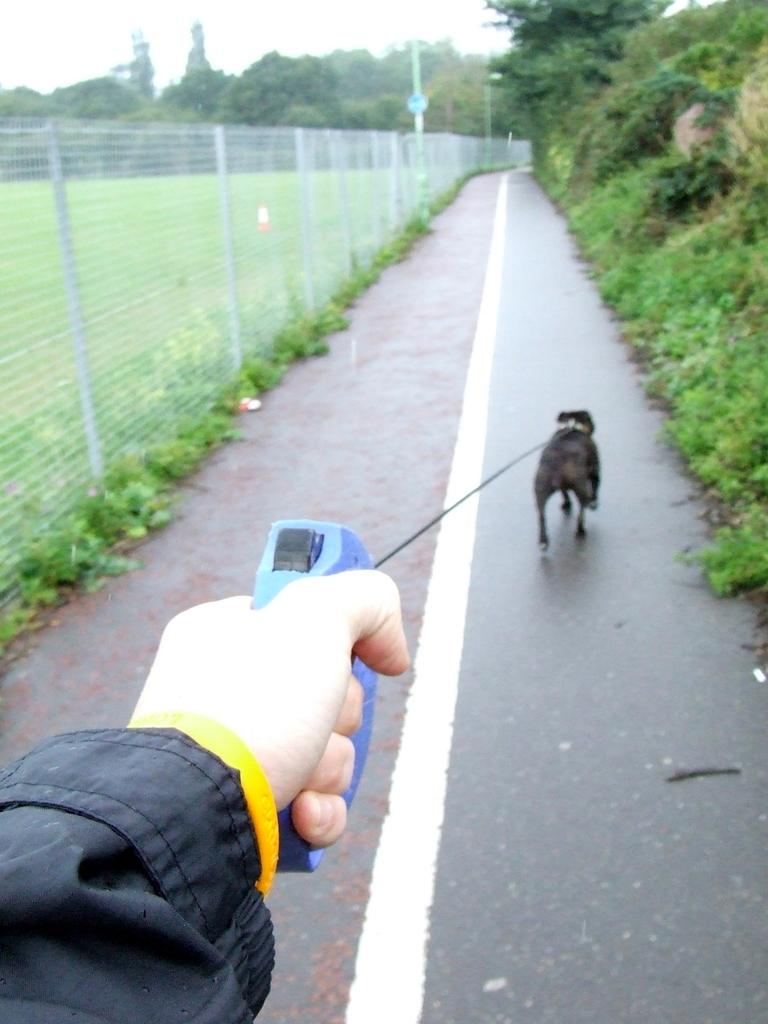What is happening in the image involving a person and a dog? The person is holding the belt of a dog in the image. Where is the dog located in the image? The dog is on the road in the image. What type of vegetation can be seen in the image? There is grass, plants, and trees visible in the image. What structures are present in the image? There is a wire fence and poles visible in the image. What can be seen in the background of the image? The sky is visible in the background of the image. Can you hear the sound of the faucet running in the image? There is no faucet present in the image, so it is not possible to hear any sound from it. What type of frog can be seen hopping on the grass in the image? There is no frog present in the image; it features a person holding a dog's belt on the road. 